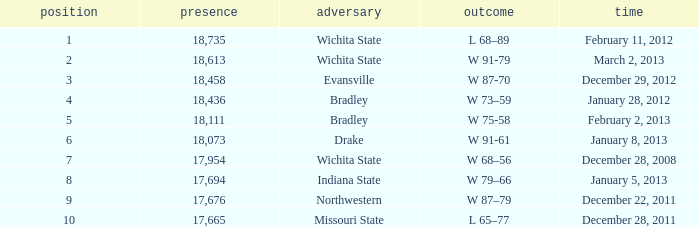What's the rank when attendance was less than 18,073 and having Northwestern as an opponent? 9.0. 